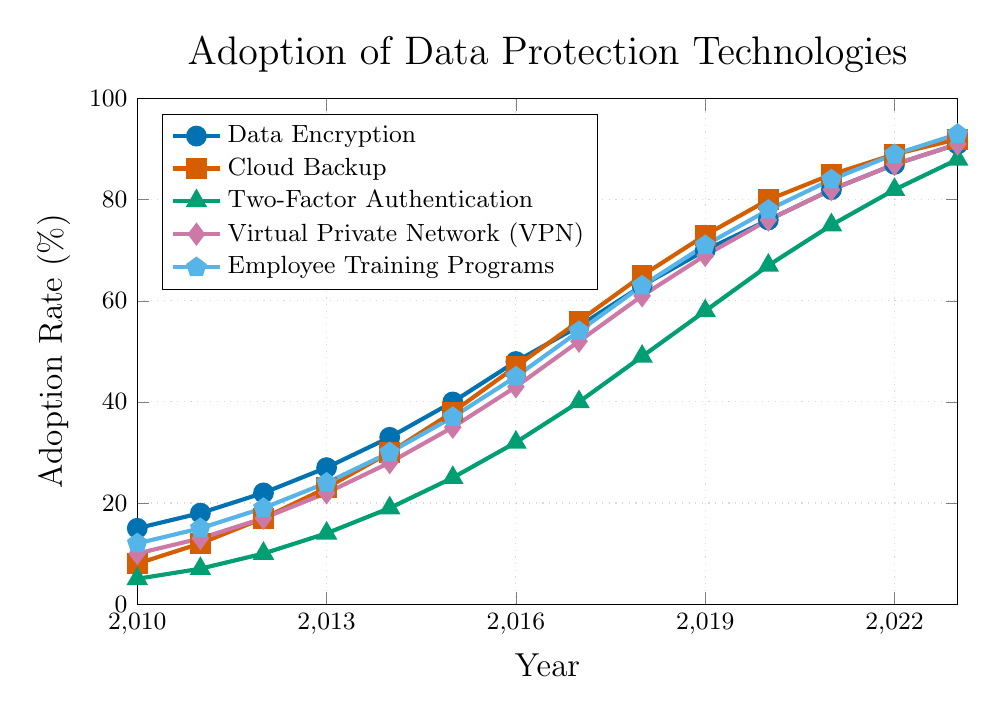How much did the adoption rate for Cloud Backup increase from 2010 to 2023? Look at the adoption rate for Cloud Backup in 2010, which is 8%, and in 2023, which is 92%. Subtract 8 from 92 to get the increase.
Answer: 84% Which data protection technology had the highest adoption rate in 2018? In 2018, Data Encryption (63%), Cloud Backup (65%), Two-Factor Authentication (49%), VPN (61%), and Employee Training Programs (63%) are the technologies. The highest adoption rate was for Cloud Backup (65%).
Answer: Cloud Backup What is the average adoption rate for Employee Training Programs between 2019 and 2023? The adoption rates for Employee Training Programs from 2019 to 2023 are 71%, 78%, 84%, 89%, and 93%. Sum these values to get 415, and divide by the number of years, which is 5.
Answer: 83% Compare the adoption rates of Data Encryption and VPN in 2016. Which one had a higher rate and by how much? The adoption rate for Data Encryption in 2016 is 48%, and for VPN, it's 43%. Subtract 43 from 48 to find out how much higher Data Encryption is.
Answer: Data Encryption by 5% What is the combined adoption rate for all five technologies in 2015? In 2015, the adoption rates are Data Encryption (40%), Cloud Backup (38%), Two-Factor Authentication (25%), VPN (35%), and Employee Training Programs (37%). Sum these values: 40 + 38 + 25 + 35 + 37 = 175.
Answer: 175% Which technology had the lowest adoption rate in 2021, and what was the rate? In 2021, Data Encryption (82%), Cloud Backup (85%), Two-Factor Authentication (75%), VPN (82%), and Employee Training Programs (84%). The lowest adoption rate among these is Two-Factor Authentication (75%).
Answer: Two-Factor Authentication, 75% By how much did the adoption of Two-Factor Authentication grow between 2013 and 2020? In 2013, the adoption rate for Two-Factor Authentication was 14%, and in 2020, it was 67%. Subtract 14 from 67 to determine the growth.
Answer: 53% What is the trend in adoption rate for Employee Training Programs from 2010 to 2023? The adoption rate for Employee Training Programs consistently increased each year from 12% in 2010 to 93% in 2023.
Answer: Increasing trend Which year saw the highest single-year growth for Virtual Private Networks (VPN), and what was the growth? By looking at the consecutive year differences, the highest single-year growth for VPN occurred between 2016 (43%) and 2017 (52%). Subtract 43 from 52 for the growth.
Answer: 2016-2017, 9% Compare the adoption rates for Data Encryption and Cloud Backup in 2015. Which technology had a higher rate and by how much? The adoption rate for Data Encryption in 2015 is 40%, and for Cloud Backup, it is 38%. Subtract 38 from 40 to determine the difference.
Answer: Data Encryption by 2% 